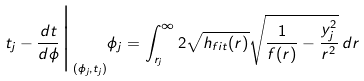Convert formula to latex. <formula><loc_0><loc_0><loc_500><loc_500>t _ { j } - \frac { d t } { d \phi } \Big | _ { ( \phi _ { j } , t _ { j } ) } \phi _ { j } = \int _ { r _ { j } } ^ { \infty } 2 \sqrt { h _ { f i t } ( r ) } \sqrt { \frac { 1 } { f ( r ) } - \frac { y _ { j } ^ { 2 } } { r ^ { 2 } } } \, d r</formula> 